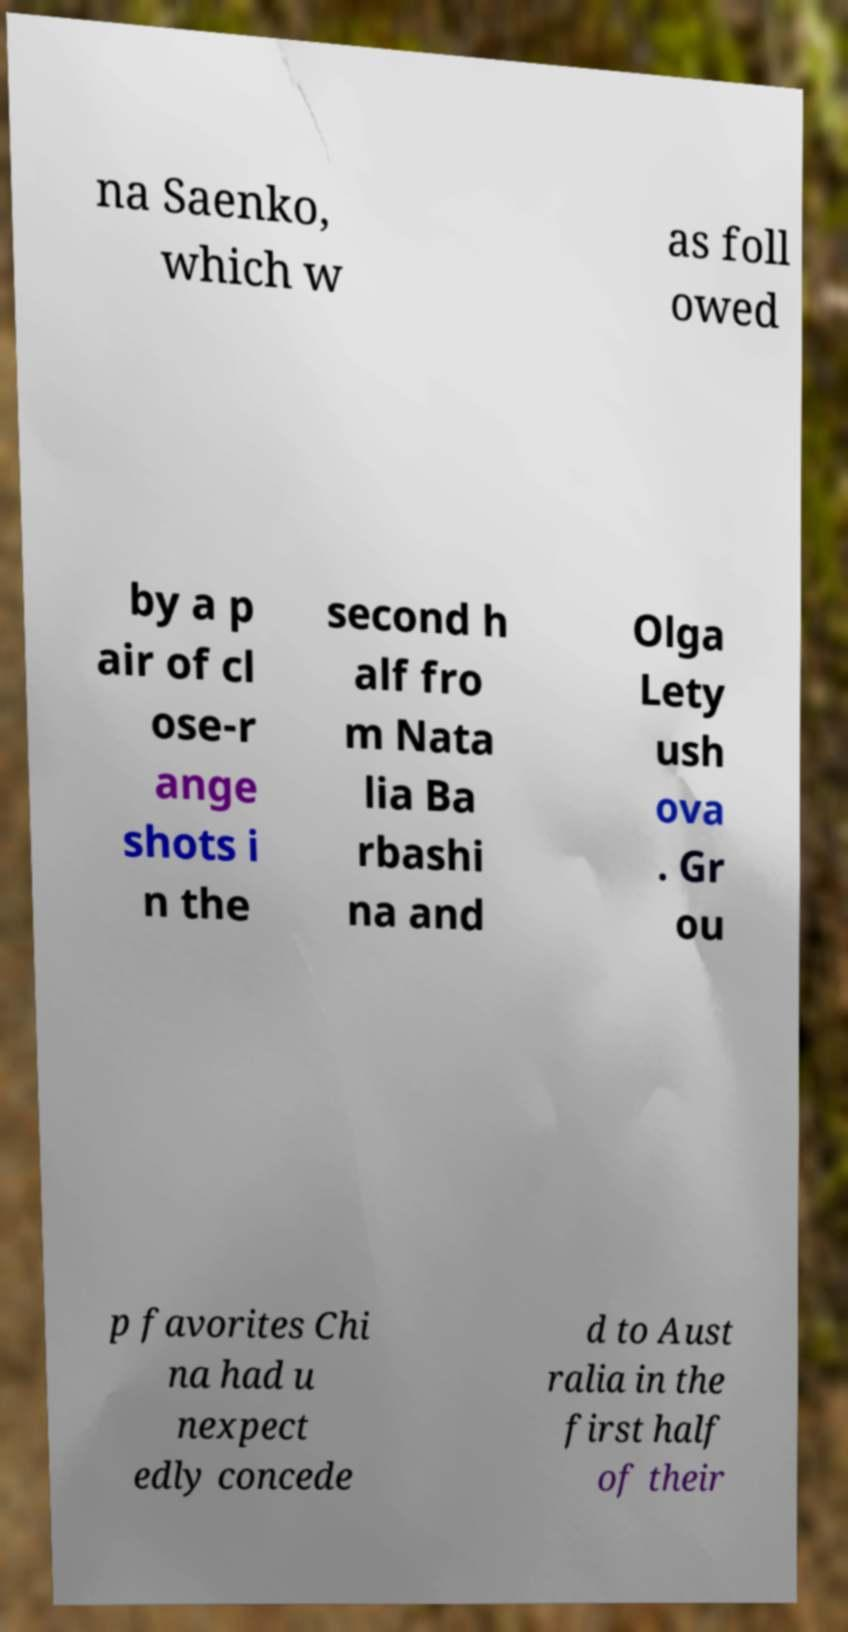I need the written content from this picture converted into text. Can you do that? na Saenko, which w as foll owed by a p air of cl ose-r ange shots i n the second h alf fro m Nata lia Ba rbashi na and Olga Lety ush ova . Gr ou p favorites Chi na had u nexpect edly concede d to Aust ralia in the first half of their 